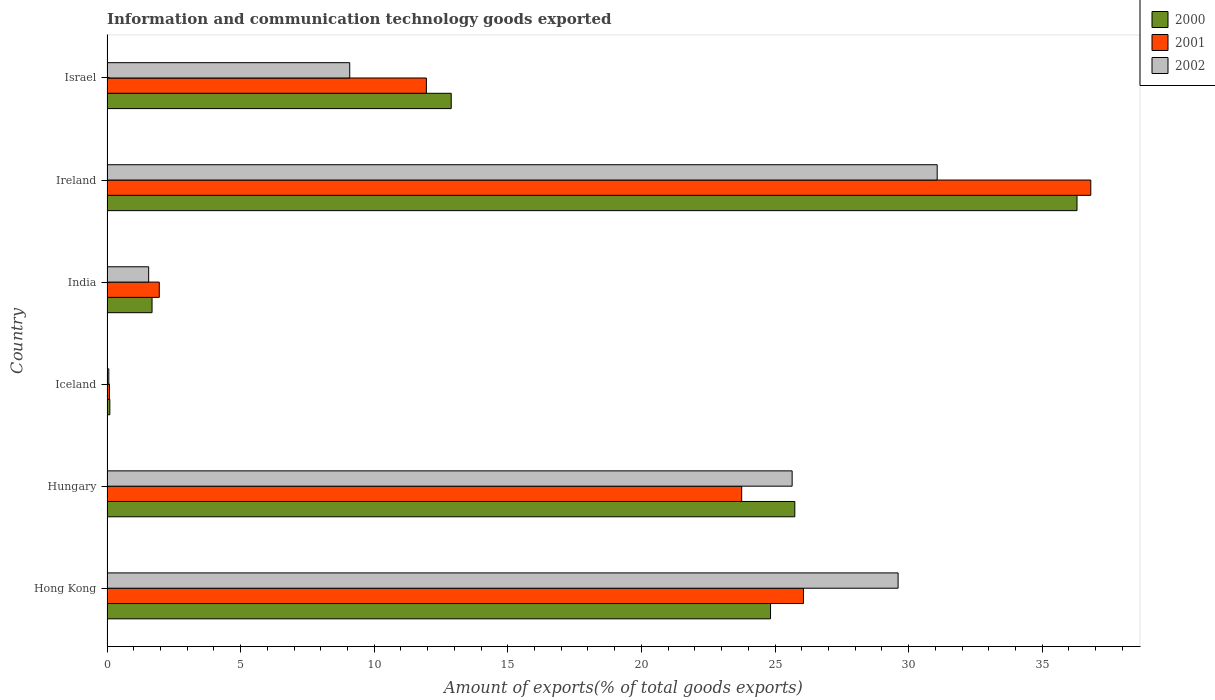How many different coloured bars are there?
Your answer should be compact. 3. How many groups of bars are there?
Ensure brevity in your answer.  6. Are the number of bars per tick equal to the number of legend labels?
Ensure brevity in your answer.  Yes. How many bars are there on the 4th tick from the top?
Offer a terse response. 3. How many bars are there on the 4th tick from the bottom?
Provide a short and direct response. 3. What is the label of the 2nd group of bars from the top?
Ensure brevity in your answer.  Ireland. What is the amount of goods exported in 2001 in Hungary?
Give a very brief answer. 23.75. Across all countries, what is the maximum amount of goods exported in 2002?
Your answer should be compact. 31.07. Across all countries, what is the minimum amount of goods exported in 2002?
Provide a succinct answer. 0.07. In which country was the amount of goods exported in 2001 maximum?
Offer a very short reply. Ireland. What is the total amount of goods exported in 2002 in the graph?
Offer a very short reply. 97.03. What is the difference between the amount of goods exported in 2000 in Hungary and that in Israel?
Your answer should be very brief. 12.86. What is the difference between the amount of goods exported in 2002 in Hong Kong and the amount of goods exported in 2001 in Ireland?
Make the answer very short. -7.21. What is the average amount of goods exported in 2001 per country?
Provide a succinct answer. 16.77. What is the difference between the amount of goods exported in 2001 and amount of goods exported in 2002 in Ireland?
Provide a succinct answer. 5.75. What is the ratio of the amount of goods exported in 2000 in Hong Kong to that in Israel?
Your response must be concise. 1.93. Is the amount of goods exported in 2002 in Hong Kong less than that in Israel?
Offer a terse response. No. Is the difference between the amount of goods exported in 2001 in Hong Kong and India greater than the difference between the amount of goods exported in 2002 in Hong Kong and India?
Offer a very short reply. No. What is the difference between the highest and the second highest amount of goods exported in 2001?
Your answer should be compact. 10.75. What is the difference between the highest and the lowest amount of goods exported in 2002?
Make the answer very short. 31. Is the sum of the amount of goods exported in 2002 in Ireland and Israel greater than the maximum amount of goods exported in 2000 across all countries?
Offer a very short reply. Yes. What does the 1st bar from the top in Israel represents?
Your answer should be compact. 2002. Is it the case that in every country, the sum of the amount of goods exported in 2001 and amount of goods exported in 2002 is greater than the amount of goods exported in 2000?
Offer a terse response. Yes. How many bars are there?
Provide a short and direct response. 18. Are all the bars in the graph horizontal?
Your answer should be very brief. Yes. How many countries are there in the graph?
Your answer should be very brief. 6. Does the graph contain any zero values?
Your response must be concise. No. Does the graph contain grids?
Make the answer very short. No. How are the legend labels stacked?
Your answer should be very brief. Vertical. What is the title of the graph?
Provide a short and direct response. Information and communication technology goods exported. What is the label or title of the X-axis?
Offer a very short reply. Amount of exports(% of total goods exports). What is the Amount of exports(% of total goods exports) in 2000 in Hong Kong?
Your answer should be very brief. 24.83. What is the Amount of exports(% of total goods exports) in 2001 in Hong Kong?
Ensure brevity in your answer.  26.07. What is the Amount of exports(% of total goods exports) in 2002 in Hong Kong?
Offer a very short reply. 29.61. What is the Amount of exports(% of total goods exports) of 2000 in Hungary?
Your answer should be very brief. 25.74. What is the Amount of exports(% of total goods exports) in 2001 in Hungary?
Make the answer very short. 23.75. What is the Amount of exports(% of total goods exports) of 2002 in Hungary?
Give a very brief answer. 25.64. What is the Amount of exports(% of total goods exports) of 2000 in Iceland?
Offer a terse response. 0.11. What is the Amount of exports(% of total goods exports) of 2001 in Iceland?
Offer a terse response. 0.09. What is the Amount of exports(% of total goods exports) of 2002 in Iceland?
Provide a succinct answer. 0.07. What is the Amount of exports(% of total goods exports) of 2000 in India?
Your answer should be compact. 1.69. What is the Amount of exports(% of total goods exports) of 2001 in India?
Give a very brief answer. 1.96. What is the Amount of exports(% of total goods exports) in 2002 in India?
Your response must be concise. 1.56. What is the Amount of exports(% of total goods exports) of 2000 in Ireland?
Keep it short and to the point. 36.3. What is the Amount of exports(% of total goods exports) in 2001 in Ireland?
Provide a short and direct response. 36.82. What is the Amount of exports(% of total goods exports) of 2002 in Ireland?
Keep it short and to the point. 31.07. What is the Amount of exports(% of total goods exports) in 2000 in Israel?
Provide a short and direct response. 12.88. What is the Amount of exports(% of total goods exports) of 2001 in Israel?
Ensure brevity in your answer.  11.95. What is the Amount of exports(% of total goods exports) of 2002 in Israel?
Provide a succinct answer. 9.08. Across all countries, what is the maximum Amount of exports(% of total goods exports) of 2000?
Ensure brevity in your answer.  36.3. Across all countries, what is the maximum Amount of exports(% of total goods exports) in 2001?
Offer a very short reply. 36.82. Across all countries, what is the maximum Amount of exports(% of total goods exports) in 2002?
Keep it short and to the point. 31.07. Across all countries, what is the minimum Amount of exports(% of total goods exports) of 2000?
Offer a very short reply. 0.11. Across all countries, what is the minimum Amount of exports(% of total goods exports) in 2001?
Provide a short and direct response. 0.09. Across all countries, what is the minimum Amount of exports(% of total goods exports) of 2002?
Keep it short and to the point. 0.07. What is the total Amount of exports(% of total goods exports) in 2000 in the graph?
Your answer should be very brief. 101.55. What is the total Amount of exports(% of total goods exports) of 2001 in the graph?
Your answer should be compact. 100.64. What is the total Amount of exports(% of total goods exports) of 2002 in the graph?
Your response must be concise. 97.03. What is the difference between the Amount of exports(% of total goods exports) in 2000 in Hong Kong and that in Hungary?
Provide a succinct answer. -0.91. What is the difference between the Amount of exports(% of total goods exports) of 2001 in Hong Kong and that in Hungary?
Provide a short and direct response. 2.31. What is the difference between the Amount of exports(% of total goods exports) of 2002 in Hong Kong and that in Hungary?
Provide a succinct answer. 3.97. What is the difference between the Amount of exports(% of total goods exports) in 2000 in Hong Kong and that in Iceland?
Your answer should be compact. 24.73. What is the difference between the Amount of exports(% of total goods exports) in 2001 in Hong Kong and that in Iceland?
Offer a very short reply. 25.98. What is the difference between the Amount of exports(% of total goods exports) of 2002 in Hong Kong and that in Iceland?
Offer a terse response. 29.54. What is the difference between the Amount of exports(% of total goods exports) of 2000 in Hong Kong and that in India?
Ensure brevity in your answer.  23.15. What is the difference between the Amount of exports(% of total goods exports) in 2001 in Hong Kong and that in India?
Provide a short and direct response. 24.11. What is the difference between the Amount of exports(% of total goods exports) in 2002 in Hong Kong and that in India?
Your response must be concise. 28.05. What is the difference between the Amount of exports(% of total goods exports) of 2000 in Hong Kong and that in Ireland?
Give a very brief answer. -11.47. What is the difference between the Amount of exports(% of total goods exports) of 2001 in Hong Kong and that in Ireland?
Your answer should be compact. -10.75. What is the difference between the Amount of exports(% of total goods exports) of 2002 in Hong Kong and that in Ireland?
Keep it short and to the point. -1.46. What is the difference between the Amount of exports(% of total goods exports) of 2000 in Hong Kong and that in Israel?
Offer a terse response. 11.95. What is the difference between the Amount of exports(% of total goods exports) in 2001 in Hong Kong and that in Israel?
Ensure brevity in your answer.  14.11. What is the difference between the Amount of exports(% of total goods exports) in 2002 in Hong Kong and that in Israel?
Ensure brevity in your answer.  20.52. What is the difference between the Amount of exports(% of total goods exports) in 2000 in Hungary and that in Iceland?
Offer a terse response. 25.64. What is the difference between the Amount of exports(% of total goods exports) of 2001 in Hungary and that in Iceland?
Your answer should be very brief. 23.66. What is the difference between the Amount of exports(% of total goods exports) in 2002 in Hungary and that in Iceland?
Your answer should be very brief. 25.57. What is the difference between the Amount of exports(% of total goods exports) of 2000 in Hungary and that in India?
Provide a succinct answer. 24.06. What is the difference between the Amount of exports(% of total goods exports) of 2001 in Hungary and that in India?
Make the answer very short. 21.8. What is the difference between the Amount of exports(% of total goods exports) in 2002 in Hungary and that in India?
Your answer should be very brief. 24.08. What is the difference between the Amount of exports(% of total goods exports) of 2000 in Hungary and that in Ireland?
Your response must be concise. -10.56. What is the difference between the Amount of exports(% of total goods exports) of 2001 in Hungary and that in Ireland?
Offer a very short reply. -13.07. What is the difference between the Amount of exports(% of total goods exports) of 2002 in Hungary and that in Ireland?
Your answer should be very brief. -5.43. What is the difference between the Amount of exports(% of total goods exports) of 2000 in Hungary and that in Israel?
Make the answer very short. 12.86. What is the difference between the Amount of exports(% of total goods exports) of 2001 in Hungary and that in Israel?
Your response must be concise. 11.8. What is the difference between the Amount of exports(% of total goods exports) in 2002 in Hungary and that in Israel?
Offer a very short reply. 16.56. What is the difference between the Amount of exports(% of total goods exports) in 2000 in Iceland and that in India?
Offer a terse response. -1.58. What is the difference between the Amount of exports(% of total goods exports) of 2001 in Iceland and that in India?
Offer a very short reply. -1.87. What is the difference between the Amount of exports(% of total goods exports) in 2002 in Iceland and that in India?
Offer a terse response. -1.49. What is the difference between the Amount of exports(% of total goods exports) in 2000 in Iceland and that in Ireland?
Offer a very short reply. -36.2. What is the difference between the Amount of exports(% of total goods exports) in 2001 in Iceland and that in Ireland?
Give a very brief answer. -36.73. What is the difference between the Amount of exports(% of total goods exports) of 2002 in Iceland and that in Ireland?
Provide a succinct answer. -31. What is the difference between the Amount of exports(% of total goods exports) of 2000 in Iceland and that in Israel?
Ensure brevity in your answer.  -12.78. What is the difference between the Amount of exports(% of total goods exports) of 2001 in Iceland and that in Israel?
Make the answer very short. -11.86. What is the difference between the Amount of exports(% of total goods exports) of 2002 in Iceland and that in Israel?
Provide a succinct answer. -9.02. What is the difference between the Amount of exports(% of total goods exports) in 2000 in India and that in Ireland?
Your answer should be very brief. -34.62. What is the difference between the Amount of exports(% of total goods exports) of 2001 in India and that in Ireland?
Your answer should be very brief. -34.86. What is the difference between the Amount of exports(% of total goods exports) of 2002 in India and that in Ireland?
Offer a terse response. -29.51. What is the difference between the Amount of exports(% of total goods exports) of 2000 in India and that in Israel?
Provide a short and direct response. -11.2. What is the difference between the Amount of exports(% of total goods exports) in 2001 in India and that in Israel?
Provide a short and direct response. -10. What is the difference between the Amount of exports(% of total goods exports) of 2002 in India and that in Israel?
Offer a very short reply. -7.52. What is the difference between the Amount of exports(% of total goods exports) of 2000 in Ireland and that in Israel?
Make the answer very short. 23.42. What is the difference between the Amount of exports(% of total goods exports) in 2001 in Ireland and that in Israel?
Your answer should be very brief. 24.87. What is the difference between the Amount of exports(% of total goods exports) of 2002 in Ireland and that in Israel?
Your response must be concise. 21.99. What is the difference between the Amount of exports(% of total goods exports) of 2000 in Hong Kong and the Amount of exports(% of total goods exports) of 2001 in Hungary?
Your answer should be compact. 1.08. What is the difference between the Amount of exports(% of total goods exports) of 2000 in Hong Kong and the Amount of exports(% of total goods exports) of 2002 in Hungary?
Your response must be concise. -0.81. What is the difference between the Amount of exports(% of total goods exports) in 2001 in Hong Kong and the Amount of exports(% of total goods exports) in 2002 in Hungary?
Offer a terse response. 0.42. What is the difference between the Amount of exports(% of total goods exports) in 2000 in Hong Kong and the Amount of exports(% of total goods exports) in 2001 in Iceland?
Provide a succinct answer. 24.74. What is the difference between the Amount of exports(% of total goods exports) in 2000 in Hong Kong and the Amount of exports(% of total goods exports) in 2002 in Iceland?
Offer a very short reply. 24.77. What is the difference between the Amount of exports(% of total goods exports) in 2001 in Hong Kong and the Amount of exports(% of total goods exports) in 2002 in Iceland?
Give a very brief answer. 26. What is the difference between the Amount of exports(% of total goods exports) in 2000 in Hong Kong and the Amount of exports(% of total goods exports) in 2001 in India?
Provide a succinct answer. 22.88. What is the difference between the Amount of exports(% of total goods exports) of 2000 in Hong Kong and the Amount of exports(% of total goods exports) of 2002 in India?
Your response must be concise. 23.27. What is the difference between the Amount of exports(% of total goods exports) in 2001 in Hong Kong and the Amount of exports(% of total goods exports) in 2002 in India?
Offer a terse response. 24.51. What is the difference between the Amount of exports(% of total goods exports) of 2000 in Hong Kong and the Amount of exports(% of total goods exports) of 2001 in Ireland?
Your answer should be compact. -11.99. What is the difference between the Amount of exports(% of total goods exports) in 2000 in Hong Kong and the Amount of exports(% of total goods exports) in 2002 in Ireland?
Make the answer very short. -6.24. What is the difference between the Amount of exports(% of total goods exports) of 2001 in Hong Kong and the Amount of exports(% of total goods exports) of 2002 in Ireland?
Offer a terse response. -5. What is the difference between the Amount of exports(% of total goods exports) of 2000 in Hong Kong and the Amount of exports(% of total goods exports) of 2001 in Israel?
Give a very brief answer. 12.88. What is the difference between the Amount of exports(% of total goods exports) in 2000 in Hong Kong and the Amount of exports(% of total goods exports) in 2002 in Israel?
Keep it short and to the point. 15.75. What is the difference between the Amount of exports(% of total goods exports) of 2001 in Hong Kong and the Amount of exports(% of total goods exports) of 2002 in Israel?
Give a very brief answer. 16.98. What is the difference between the Amount of exports(% of total goods exports) in 2000 in Hungary and the Amount of exports(% of total goods exports) in 2001 in Iceland?
Offer a very short reply. 25.65. What is the difference between the Amount of exports(% of total goods exports) of 2000 in Hungary and the Amount of exports(% of total goods exports) of 2002 in Iceland?
Make the answer very short. 25.67. What is the difference between the Amount of exports(% of total goods exports) in 2001 in Hungary and the Amount of exports(% of total goods exports) in 2002 in Iceland?
Offer a very short reply. 23.69. What is the difference between the Amount of exports(% of total goods exports) in 2000 in Hungary and the Amount of exports(% of total goods exports) in 2001 in India?
Give a very brief answer. 23.79. What is the difference between the Amount of exports(% of total goods exports) in 2000 in Hungary and the Amount of exports(% of total goods exports) in 2002 in India?
Your response must be concise. 24.18. What is the difference between the Amount of exports(% of total goods exports) of 2001 in Hungary and the Amount of exports(% of total goods exports) of 2002 in India?
Your answer should be compact. 22.19. What is the difference between the Amount of exports(% of total goods exports) of 2000 in Hungary and the Amount of exports(% of total goods exports) of 2001 in Ireland?
Your answer should be compact. -11.08. What is the difference between the Amount of exports(% of total goods exports) of 2000 in Hungary and the Amount of exports(% of total goods exports) of 2002 in Ireland?
Your response must be concise. -5.33. What is the difference between the Amount of exports(% of total goods exports) of 2001 in Hungary and the Amount of exports(% of total goods exports) of 2002 in Ireland?
Keep it short and to the point. -7.32. What is the difference between the Amount of exports(% of total goods exports) in 2000 in Hungary and the Amount of exports(% of total goods exports) in 2001 in Israel?
Give a very brief answer. 13.79. What is the difference between the Amount of exports(% of total goods exports) in 2000 in Hungary and the Amount of exports(% of total goods exports) in 2002 in Israel?
Offer a terse response. 16.66. What is the difference between the Amount of exports(% of total goods exports) in 2001 in Hungary and the Amount of exports(% of total goods exports) in 2002 in Israel?
Offer a very short reply. 14.67. What is the difference between the Amount of exports(% of total goods exports) in 2000 in Iceland and the Amount of exports(% of total goods exports) in 2001 in India?
Offer a very short reply. -1.85. What is the difference between the Amount of exports(% of total goods exports) in 2000 in Iceland and the Amount of exports(% of total goods exports) in 2002 in India?
Provide a short and direct response. -1.45. What is the difference between the Amount of exports(% of total goods exports) in 2001 in Iceland and the Amount of exports(% of total goods exports) in 2002 in India?
Your answer should be compact. -1.47. What is the difference between the Amount of exports(% of total goods exports) in 2000 in Iceland and the Amount of exports(% of total goods exports) in 2001 in Ireland?
Keep it short and to the point. -36.71. What is the difference between the Amount of exports(% of total goods exports) of 2000 in Iceland and the Amount of exports(% of total goods exports) of 2002 in Ireland?
Keep it short and to the point. -30.96. What is the difference between the Amount of exports(% of total goods exports) of 2001 in Iceland and the Amount of exports(% of total goods exports) of 2002 in Ireland?
Provide a succinct answer. -30.98. What is the difference between the Amount of exports(% of total goods exports) of 2000 in Iceland and the Amount of exports(% of total goods exports) of 2001 in Israel?
Keep it short and to the point. -11.85. What is the difference between the Amount of exports(% of total goods exports) in 2000 in Iceland and the Amount of exports(% of total goods exports) in 2002 in Israel?
Provide a short and direct response. -8.98. What is the difference between the Amount of exports(% of total goods exports) in 2001 in Iceland and the Amount of exports(% of total goods exports) in 2002 in Israel?
Your answer should be compact. -8.99. What is the difference between the Amount of exports(% of total goods exports) of 2000 in India and the Amount of exports(% of total goods exports) of 2001 in Ireland?
Ensure brevity in your answer.  -35.13. What is the difference between the Amount of exports(% of total goods exports) in 2000 in India and the Amount of exports(% of total goods exports) in 2002 in Ireland?
Ensure brevity in your answer.  -29.38. What is the difference between the Amount of exports(% of total goods exports) of 2001 in India and the Amount of exports(% of total goods exports) of 2002 in Ireland?
Keep it short and to the point. -29.11. What is the difference between the Amount of exports(% of total goods exports) of 2000 in India and the Amount of exports(% of total goods exports) of 2001 in Israel?
Provide a succinct answer. -10.27. What is the difference between the Amount of exports(% of total goods exports) in 2000 in India and the Amount of exports(% of total goods exports) in 2002 in Israel?
Offer a terse response. -7.4. What is the difference between the Amount of exports(% of total goods exports) of 2001 in India and the Amount of exports(% of total goods exports) of 2002 in Israel?
Offer a terse response. -7.13. What is the difference between the Amount of exports(% of total goods exports) of 2000 in Ireland and the Amount of exports(% of total goods exports) of 2001 in Israel?
Keep it short and to the point. 24.35. What is the difference between the Amount of exports(% of total goods exports) of 2000 in Ireland and the Amount of exports(% of total goods exports) of 2002 in Israel?
Offer a very short reply. 27.22. What is the difference between the Amount of exports(% of total goods exports) of 2001 in Ireland and the Amount of exports(% of total goods exports) of 2002 in Israel?
Provide a short and direct response. 27.73. What is the average Amount of exports(% of total goods exports) in 2000 per country?
Keep it short and to the point. 16.93. What is the average Amount of exports(% of total goods exports) of 2001 per country?
Offer a terse response. 16.77. What is the average Amount of exports(% of total goods exports) in 2002 per country?
Offer a very short reply. 16.17. What is the difference between the Amount of exports(% of total goods exports) of 2000 and Amount of exports(% of total goods exports) of 2001 in Hong Kong?
Offer a very short reply. -1.23. What is the difference between the Amount of exports(% of total goods exports) in 2000 and Amount of exports(% of total goods exports) in 2002 in Hong Kong?
Your response must be concise. -4.77. What is the difference between the Amount of exports(% of total goods exports) in 2001 and Amount of exports(% of total goods exports) in 2002 in Hong Kong?
Make the answer very short. -3.54. What is the difference between the Amount of exports(% of total goods exports) of 2000 and Amount of exports(% of total goods exports) of 2001 in Hungary?
Provide a short and direct response. 1.99. What is the difference between the Amount of exports(% of total goods exports) in 2000 and Amount of exports(% of total goods exports) in 2002 in Hungary?
Your answer should be very brief. 0.1. What is the difference between the Amount of exports(% of total goods exports) in 2001 and Amount of exports(% of total goods exports) in 2002 in Hungary?
Keep it short and to the point. -1.89. What is the difference between the Amount of exports(% of total goods exports) of 2000 and Amount of exports(% of total goods exports) of 2001 in Iceland?
Your answer should be very brief. 0.02. What is the difference between the Amount of exports(% of total goods exports) of 2000 and Amount of exports(% of total goods exports) of 2002 in Iceland?
Provide a succinct answer. 0.04. What is the difference between the Amount of exports(% of total goods exports) of 2001 and Amount of exports(% of total goods exports) of 2002 in Iceland?
Provide a succinct answer. 0.02. What is the difference between the Amount of exports(% of total goods exports) in 2000 and Amount of exports(% of total goods exports) in 2001 in India?
Give a very brief answer. -0.27. What is the difference between the Amount of exports(% of total goods exports) in 2000 and Amount of exports(% of total goods exports) in 2002 in India?
Offer a terse response. 0.13. What is the difference between the Amount of exports(% of total goods exports) in 2001 and Amount of exports(% of total goods exports) in 2002 in India?
Provide a short and direct response. 0.4. What is the difference between the Amount of exports(% of total goods exports) of 2000 and Amount of exports(% of total goods exports) of 2001 in Ireland?
Keep it short and to the point. -0.52. What is the difference between the Amount of exports(% of total goods exports) in 2000 and Amount of exports(% of total goods exports) in 2002 in Ireland?
Give a very brief answer. 5.23. What is the difference between the Amount of exports(% of total goods exports) of 2001 and Amount of exports(% of total goods exports) of 2002 in Ireland?
Ensure brevity in your answer.  5.75. What is the difference between the Amount of exports(% of total goods exports) of 2000 and Amount of exports(% of total goods exports) of 2001 in Israel?
Provide a short and direct response. 0.93. What is the difference between the Amount of exports(% of total goods exports) of 2000 and Amount of exports(% of total goods exports) of 2002 in Israel?
Ensure brevity in your answer.  3.8. What is the difference between the Amount of exports(% of total goods exports) of 2001 and Amount of exports(% of total goods exports) of 2002 in Israel?
Keep it short and to the point. 2.87. What is the ratio of the Amount of exports(% of total goods exports) of 2000 in Hong Kong to that in Hungary?
Make the answer very short. 0.96. What is the ratio of the Amount of exports(% of total goods exports) in 2001 in Hong Kong to that in Hungary?
Keep it short and to the point. 1.1. What is the ratio of the Amount of exports(% of total goods exports) in 2002 in Hong Kong to that in Hungary?
Ensure brevity in your answer.  1.15. What is the ratio of the Amount of exports(% of total goods exports) in 2000 in Hong Kong to that in Iceland?
Your answer should be very brief. 233.9. What is the ratio of the Amount of exports(% of total goods exports) of 2001 in Hong Kong to that in Iceland?
Ensure brevity in your answer.  288.66. What is the ratio of the Amount of exports(% of total goods exports) in 2002 in Hong Kong to that in Iceland?
Make the answer very short. 439.05. What is the ratio of the Amount of exports(% of total goods exports) of 2000 in Hong Kong to that in India?
Provide a succinct answer. 14.73. What is the ratio of the Amount of exports(% of total goods exports) in 2001 in Hong Kong to that in India?
Your answer should be very brief. 13.32. What is the ratio of the Amount of exports(% of total goods exports) of 2002 in Hong Kong to that in India?
Give a very brief answer. 18.98. What is the ratio of the Amount of exports(% of total goods exports) of 2000 in Hong Kong to that in Ireland?
Your answer should be very brief. 0.68. What is the ratio of the Amount of exports(% of total goods exports) of 2001 in Hong Kong to that in Ireland?
Provide a short and direct response. 0.71. What is the ratio of the Amount of exports(% of total goods exports) of 2002 in Hong Kong to that in Ireland?
Your answer should be compact. 0.95. What is the ratio of the Amount of exports(% of total goods exports) in 2000 in Hong Kong to that in Israel?
Give a very brief answer. 1.93. What is the ratio of the Amount of exports(% of total goods exports) of 2001 in Hong Kong to that in Israel?
Give a very brief answer. 2.18. What is the ratio of the Amount of exports(% of total goods exports) of 2002 in Hong Kong to that in Israel?
Your response must be concise. 3.26. What is the ratio of the Amount of exports(% of total goods exports) in 2000 in Hungary to that in Iceland?
Your response must be concise. 242.46. What is the ratio of the Amount of exports(% of total goods exports) of 2001 in Hungary to that in Iceland?
Give a very brief answer. 263.05. What is the ratio of the Amount of exports(% of total goods exports) in 2002 in Hungary to that in Iceland?
Ensure brevity in your answer.  380.25. What is the ratio of the Amount of exports(% of total goods exports) of 2000 in Hungary to that in India?
Make the answer very short. 15.27. What is the ratio of the Amount of exports(% of total goods exports) of 2001 in Hungary to that in India?
Offer a terse response. 12.14. What is the ratio of the Amount of exports(% of total goods exports) of 2002 in Hungary to that in India?
Provide a short and direct response. 16.44. What is the ratio of the Amount of exports(% of total goods exports) of 2000 in Hungary to that in Ireland?
Your answer should be compact. 0.71. What is the ratio of the Amount of exports(% of total goods exports) in 2001 in Hungary to that in Ireland?
Make the answer very short. 0.65. What is the ratio of the Amount of exports(% of total goods exports) of 2002 in Hungary to that in Ireland?
Offer a terse response. 0.83. What is the ratio of the Amount of exports(% of total goods exports) of 2000 in Hungary to that in Israel?
Provide a short and direct response. 2. What is the ratio of the Amount of exports(% of total goods exports) in 2001 in Hungary to that in Israel?
Offer a terse response. 1.99. What is the ratio of the Amount of exports(% of total goods exports) in 2002 in Hungary to that in Israel?
Offer a very short reply. 2.82. What is the ratio of the Amount of exports(% of total goods exports) in 2000 in Iceland to that in India?
Give a very brief answer. 0.06. What is the ratio of the Amount of exports(% of total goods exports) in 2001 in Iceland to that in India?
Provide a short and direct response. 0.05. What is the ratio of the Amount of exports(% of total goods exports) in 2002 in Iceland to that in India?
Your response must be concise. 0.04. What is the ratio of the Amount of exports(% of total goods exports) in 2000 in Iceland to that in Ireland?
Keep it short and to the point. 0. What is the ratio of the Amount of exports(% of total goods exports) of 2001 in Iceland to that in Ireland?
Offer a terse response. 0. What is the ratio of the Amount of exports(% of total goods exports) of 2002 in Iceland to that in Ireland?
Keep it short and to the point. 0. What is the ratio of the Amount of exports(% of total goods exports) of 2000 in Iceland to that in Israel?
Your answer should be very brief. 0.01. What is the ratio of the Amount of exports(% of total goods exports) of 2001 in Iceland to that in Israel?
Keep it short and to the point. 0.01. What is the ratio of the Amount of exports(% of total goods exports) in 2002 in Iceland to that in Israel?
Give a very brief answer. 0.01. What is the ratio of the Amount of exports(% of total goods exports) of 2000 in India to that in Ireland?
Keep it short and to the point. 0.05. What is the ratio of the Amount of exports(% of total goods exports) of 2001 in India to that in Ireland?
Your response must be concise. 0.05. What is the ratio of the Amount of exports(% of total goods exports) of 2002 in India to that in Ireland?
Your response must be concise. 0.05. What is the ratio of the Amount of exports(% of total goods exports) of 2000 in India to that in Israel?
Offer a very short reply. 0.13. What is the ratio of the Amount of exports(% of total goods exports) of 2001 in India to that in Israel?
Offer a very short reply. 0.16. What is the ratio of the Amount of exports(% of total goods exports) of 2002 in India to that in Israel?
Ensure brevity in your answer.  0.17. What is the ratio of the Amount of exports(% of total goods exports) in 2000 in Ireland to that in Israel?
Your answer should be very brief. 2.82. What is the ratio of the Amount of exports(% of total goods exports) in 2001 in Ireland to that in Israel?
Ensure brevity in your answer.  3.08. What is the ratio of the Amount of exports(% of total goods exports) in 2002 in Ireland to that in Israel?
Provide a succinct answer. 3.42. What is the difference between the highest and the second highest Amount of exports(% of total goods exports) in 2000?
Offer a terse response. 10.56. What is the difference between the highest and the second highest Amount of exports(% of total goods exports) in 2001?
Keep it short and to the point. 10.75. What is the difference between the highest and the second highest Amount of exports(% of total goods exports) of 2002?
Make the answer very short. 1.46. What is the difference between the highest and the lowest Amount of exports(% of total goods exports) of 2000?
Offer a terse response. 36.2. What is the difference between the highest and the lowest Amount of exports(% of total goods exports) of 2001?
Ensure brevity in your answer.  36.73. What is the difference between the highest and the lowest Amount of exports(% of total goods exports) of 2002?
Make the answer very short. 31. 